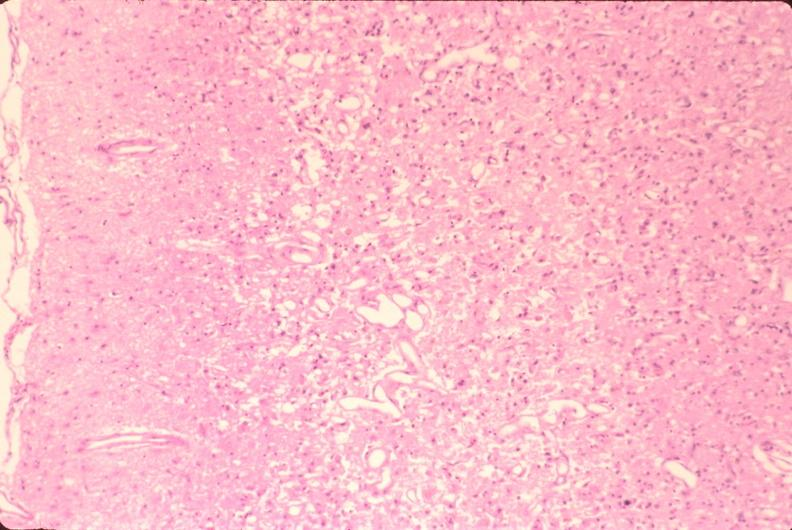does cachexia show brain, old infarcts, embolic?
Answer the question using a single word or phrase. No 